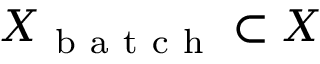Convert formula to latex. <formula><loc_0><loc_0><loc_500><loc_500>X _ { b a t c h } \subset X</formula> 